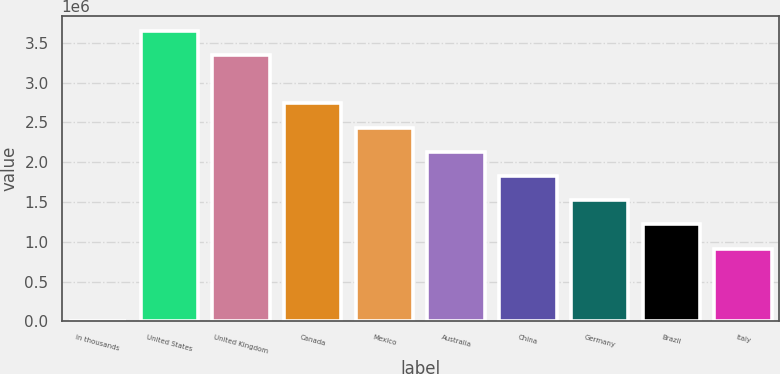Convert chart to OTSL. <chart><loc_0><loc_0><loc_500><loc_500><bar_chart><fcel>In thousands<fcel>United States<fcel>United Kingdom<fcel>Canada<fcel>Mexico<fcel>Australia<fcel>China<fcel>Germany<fcel>Brazil<fcel>Italy<nl><fcel>2014<fcel>3.65294e+06<fcel>3.3487e+06<fcel>2.74021e+06<fcel>2.43597e+06<fcel>2.13172e+06<fcel>1.82748e+06<fcel>1.52323e+06<fcel>1.21899e+06<fcel>914746<nl></chart> 